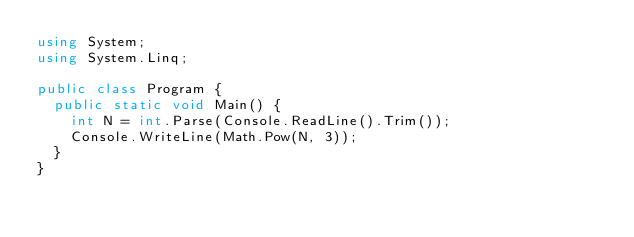<code> <loc_0><loc_0><loc_500><loc_500><_C#_>using System;
using System.Linq;

public class Program {
  public static void Main() {
    int N = int.Parse(Console.ReadLine().Trim());
    Console.WriteLine(Math.Pow(N, 3));
  }
}</code> 